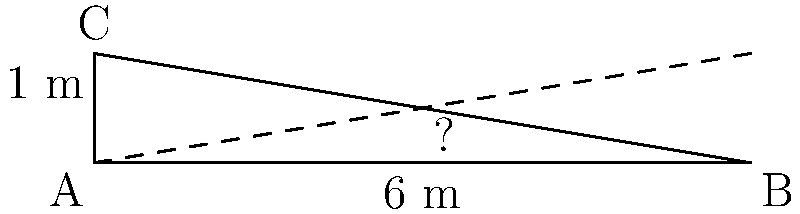As part of a social impact project, you're designing a wheelchair-accessible ramp for a community center. The building code requires a maximum slope of 1:12 for such ramps. Given a vertical rise of 1 meter, what is the minimum horizontal length of the ramp in meters to meet this requirement? Use the right triangle in the diagram to calculate your answer. Let's approach this step-by-step:

1) The slope requirement of 1:12 means that for every 1 unit of vertical rise, there must be at least 12 units of horizontal length.

2) In our case, we have a vertical rise of 1 meter. Let's call the unknown horizontal length $x$ meters.

3) We can set up a proportion based on the slope requirement:
   $$\frac{1}{12} = \frac{1}{x}$$

4) Cross multiply:
   $$1 \cdot x = 12 \cdot 1$$
   $$x = 12$$

5) Therefore, the minimum horizontal length of the ramp should be 12 meters.

6) We can verify this using the Pythagorean theorem:
   $$a^2 + b^2 = c^2$$
   $$1^2 + 12^2 = c^2$$
   $$1 + 144 = c^2$$
   $$145 = c^2$$
   $$c \approx 12.04$$

   This confirms that the length of the ramp (the hypotenuse) is slightly longer than 12 meters, which meets the requirement.
Answer: 12 meters 